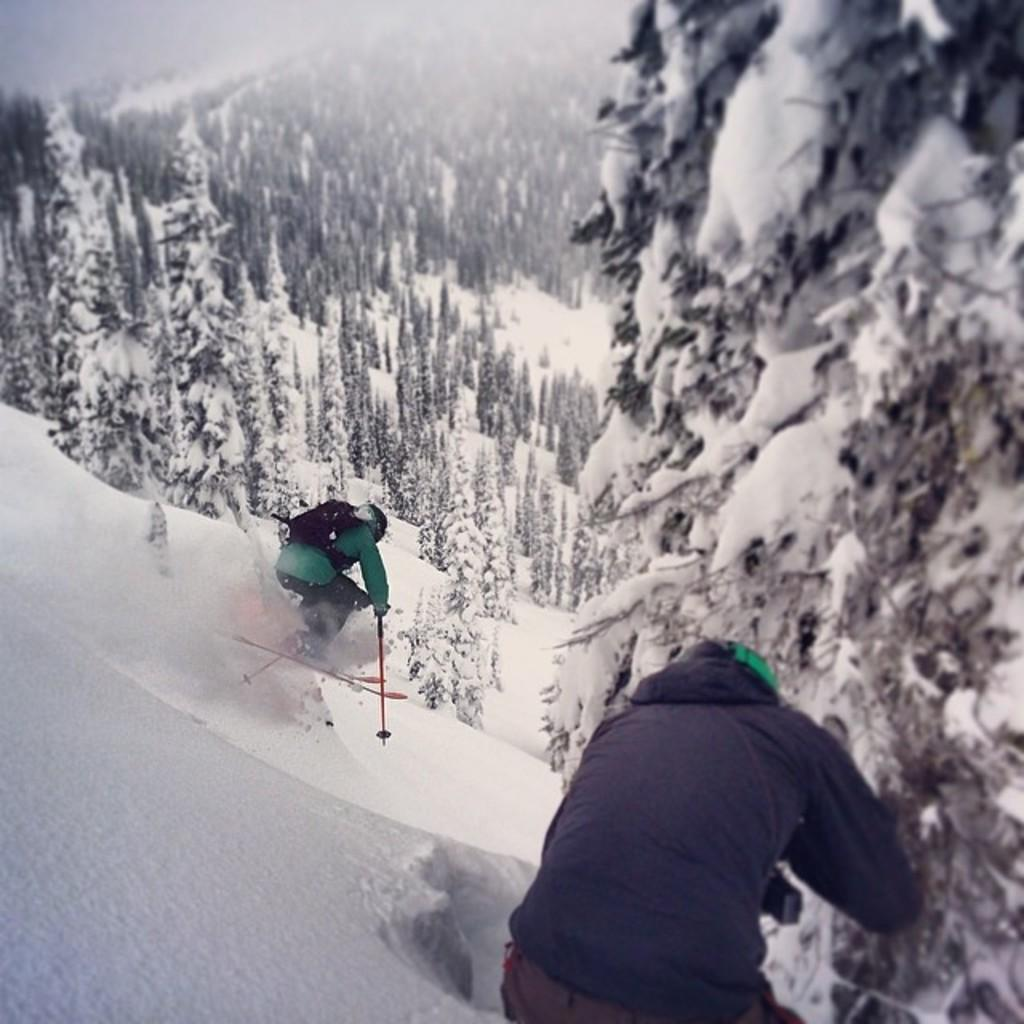How many people are in the image? There are two persons in the image. What are the persons doing in the image? The persons are skating on snow. What can be seen in the background of the image? There are trees in the background of the image. How do the trees appear in the image? The trees are covered with snow. What type of chalk is being used to draw on the snow by the persons in the image? There is no chalk present in the image; the persons are skating on snow. How does the creator of the image feel about the straw in the background? There is no straw present in the image, and we cannot determine the creator's feelings about it. 